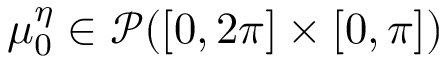<formula> <loc_0><loc_0><loc_500><loc_500>\mu _ { 0 } ^ { \eta } \in \mathcal { P } ( [ 0 , 2 \pi ] \times [ 0 , \pi ] )</formula> 